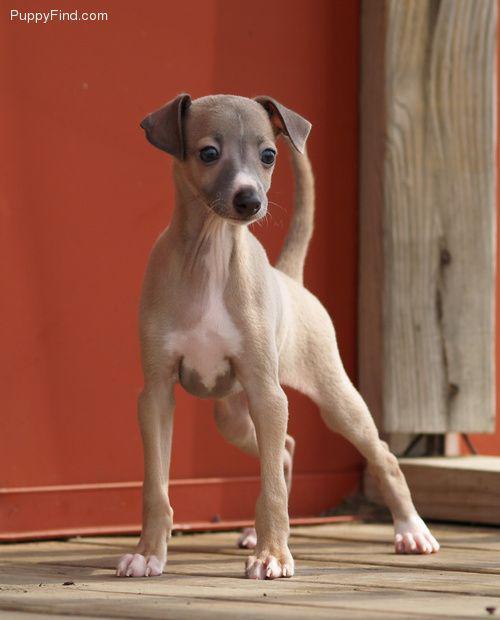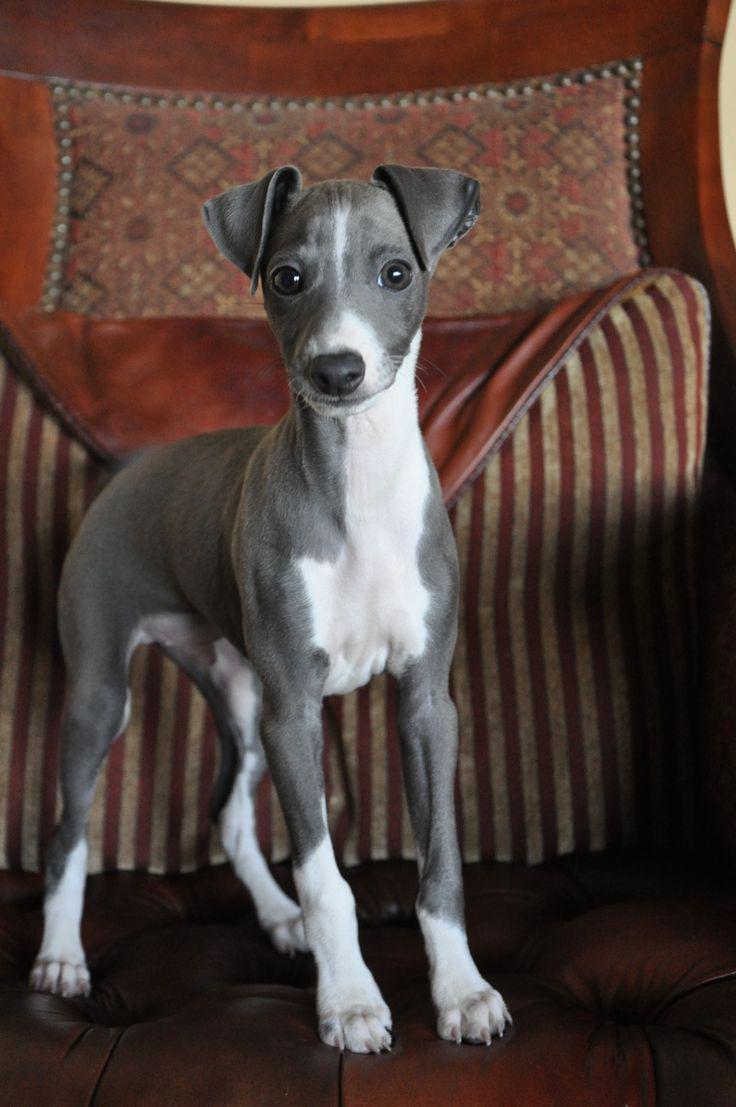The first image is the image on the left, the second image is the image on the right. Examine the images to the left and right. Is the description "At least one image shows a single dog standing up with only paws touching the ground." accurate? Answer yes or no. Yes. The first image is the image on the left, the second image is the image on the right. Evaluate the accuracy of this statement regarding the images: "Left and right images each contain one similarly posed and sized dog.". Is it true? Answer yes or no. Yes. 